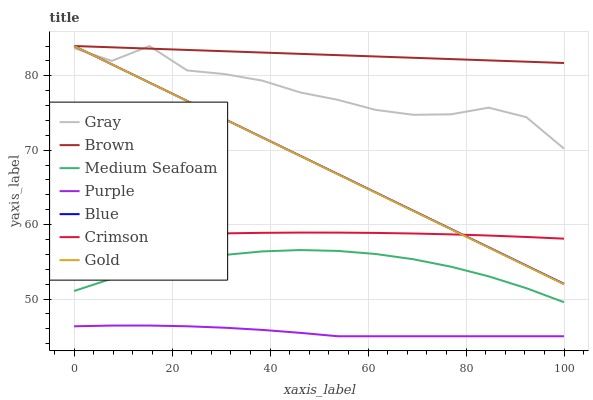Does Purple have the minimum area under the curve?
Answer yes or no. Yes. Does Brown have the maximum area under the curve?
Answer yes or no. Yes. Does Gray have the minimum area under the curve?
Answer yes or no. No. Does Gray have the maximum area under the curve?
Answer yes or no. No. Is Blue the smoothest?
Answer yes or no. Yes. Is Gray the roughest?
Answer yes or no. Yes. Is Gold the smoothest?
Answer yes or no. No. Is Gold the roughest?
Answer yes or no. No. Does Purple have the lowest value?
Answer yes or no. Yes. Does Gray have the lowest value?
Answer yes or no. No. Does Brown have the highest value?
Answer yes or no. Yes. Does Gray have the highest value?
Answer yes or no. No. Is Crimson less than Gray?
Answer yes or no. Yes. Is Blue greater than Medium Seafoam?
Answer yes or no. Yes. Does Gold intersect Gray?
Answer yes or no. Yes. Is Gold less than Gray?
Answer yes or no. No. Is Gold greater than Gray?
Answer yes or no. No. Does Crimson intersect Gray?
Answer yes or no. No. 